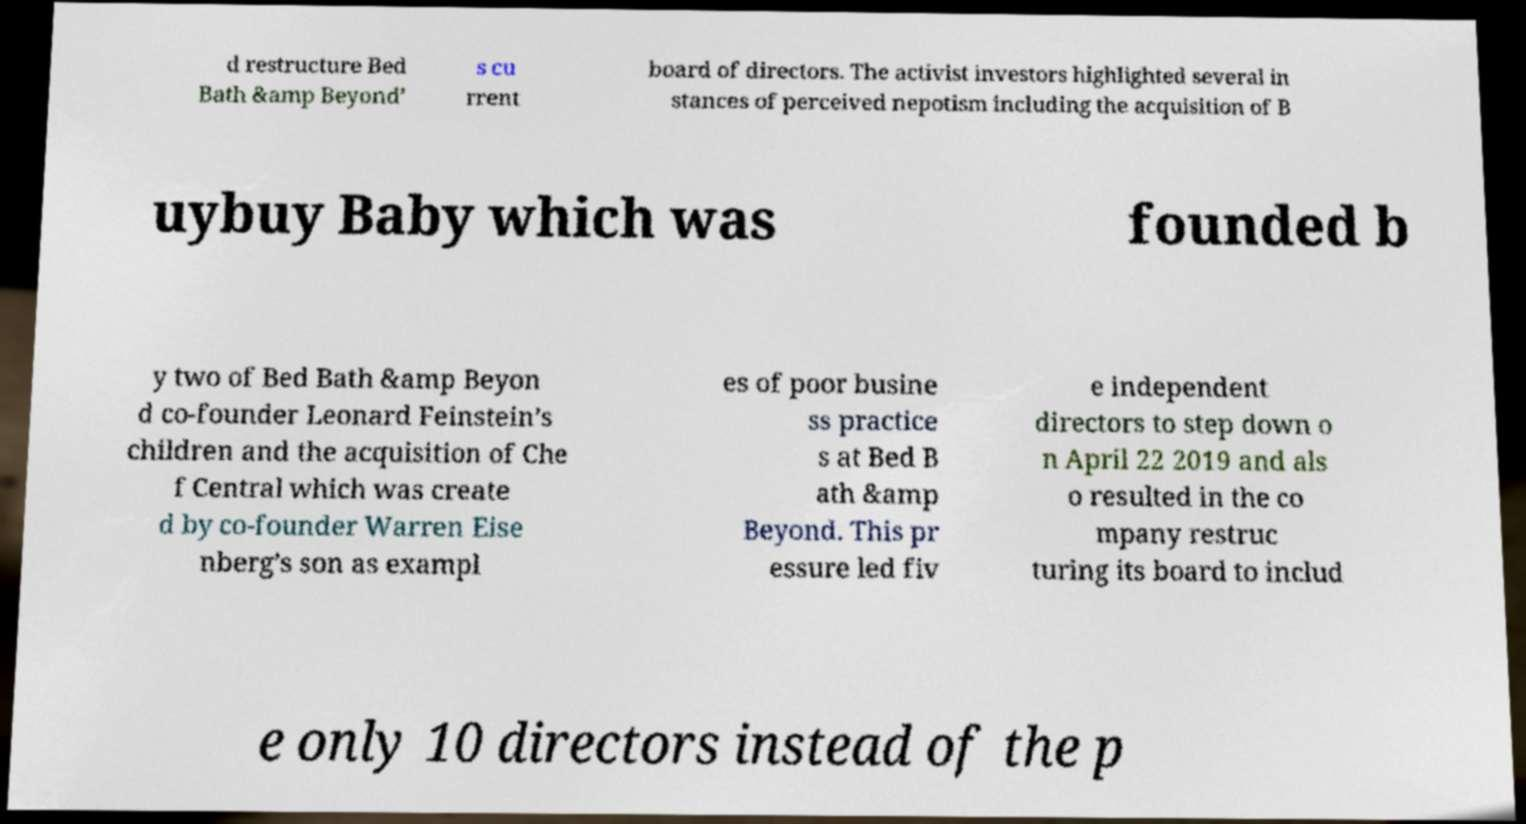Could you extract and type out the text from this image? d restructure Bed Bath &amp Beyond’ s cu rrent board of directors. The activist investors highlighted several in stances of perceived nepotism including the acquisition of B uybuy Baby which was founded b y two of Bed Bath &amp Beyon d co-founder Leonard Feinstein’s children and the acquisition of Che f Central which was create d by co-founder Warren Eise nberg’s son as exampl es of poor busine ss practice s at Bed B ath &amp Beyond. This pr essure led fiv e independent directors to step down o n April 22 2019 and als o resulted in the co mpany restruc turing its board to includ e only 10 directors instead of the p 